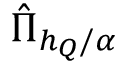Convert formula to latex. <formula><loc_0><loc_0><loc_500><loc_500>\hat { \Pi } _ { h _ { Q } / \alpha }</formula> 